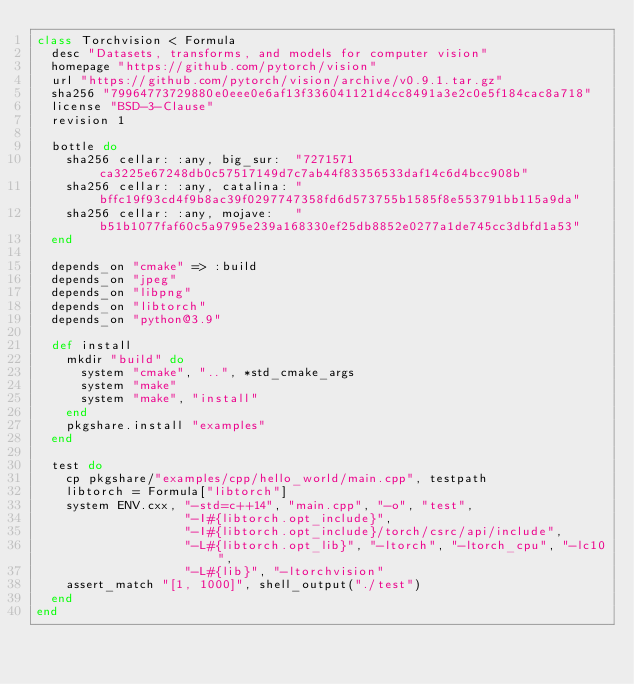<code> <loc_0><loc_0><loc_500><loc_500><_Ruby_>class Torchvision < Formula
  desc "Datasets, transforms, and models for computer vision"
  homepage "https://github.com/pytorch/vision"
  url "https://github.com/pytorch/vision/archive/v0.9.1.tar.gz"
  sha256 "79964773729880e0eee0e6af13f336041121d4cc8491a3e2c0e5f184cac8a718"
  license "BSD-3-Clause"
  revision 1

  bottle do
    sha256 cellar: :any, big_sur:  "7271571ca3225e67248db0c57517149d7c7ab44f83356533daf14c6d4bcc908b"
    sha256 cellar: :any, catalina: "bffc19f93cd4f9b8ac39f0297747358fd6d573755b1585f8e553791bb115a9da"
    sha256 cellar: :any, mojave:   "b51b1077faf60c5a9795e239a168330ef25db8852e0277a1de745cc3dbfd1a53"
  end

  depends_on "cmake" => :build
  depends_on "jpeg"
  depends_on "libpng"
  depends_on "libtorch"
  depends_on "python@3.9"

  def install
    mkdir "build" do
      system "cmake", "..", *std_cmake_args
      system "make"
      system "make", "install"
    end
    pkgshare.install "examples"
  end

  test do
    cp pkgshare/"examples/cpp/hello_world/main.cpp", testpath
    libtorch = Formula["libtorch"]
    system ENV.cxx, "-std=c++14", "main.cpp", "-o", "test",
                    "-I#{libtorch.opt_include}",
                    "-I#{libtorch.opt_include}/torch/csrc/api/include",
                    "-L#{libtorch.opt_lib}", "-ltorch", "-ltorch_cpu", "-lc10",
                    "-L#{lib}", "-ltorchvision"
    assert_match "[1, 1000]", shell_output("./test")
  end
end
</code> 